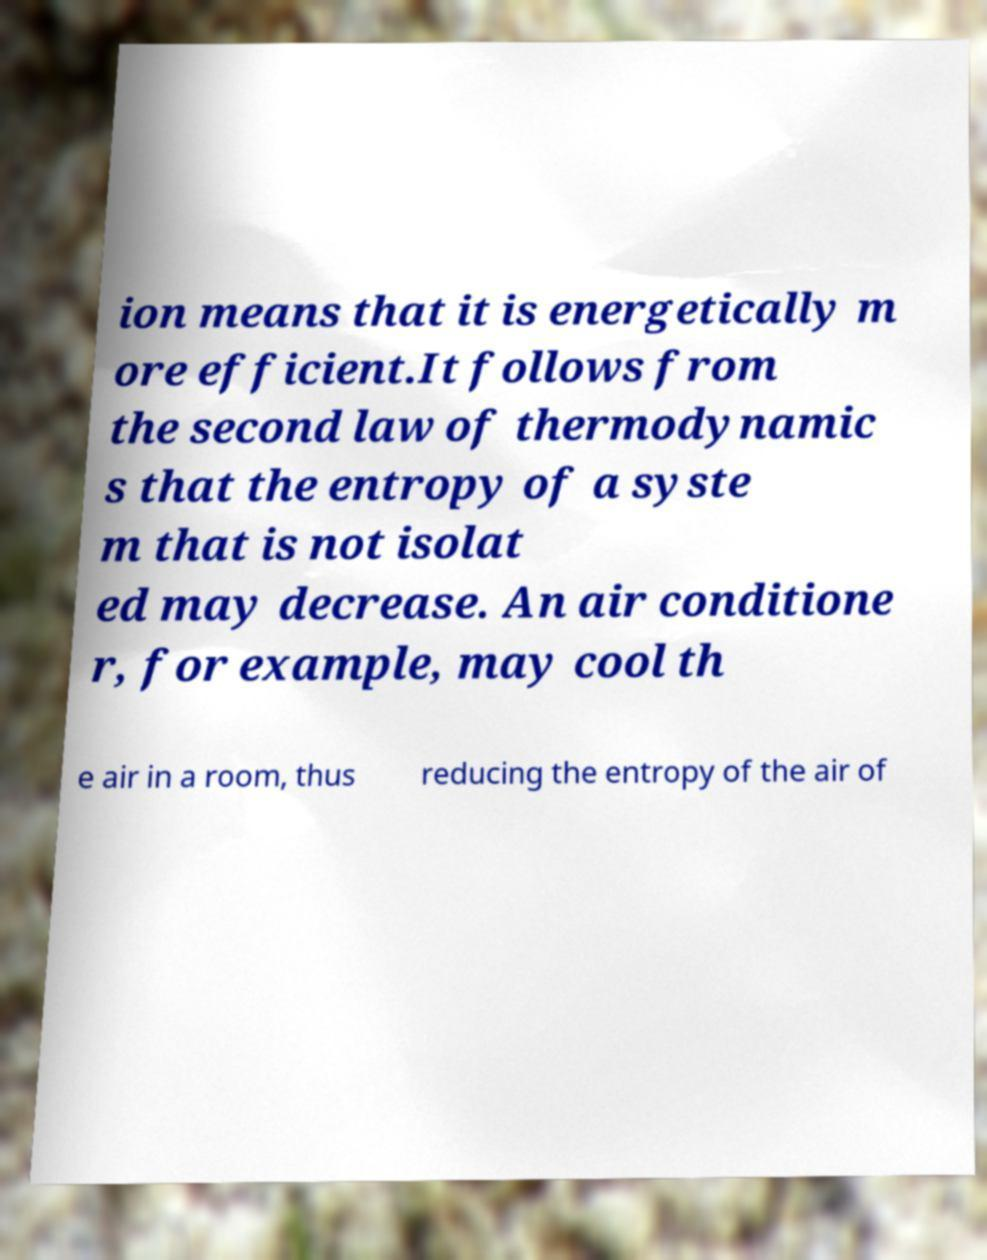Please identify and transcribe the text found in this image. ion means that it is energetically m ore efficient.It follows from the second law of thermodynamic s that the entropy of a syste m that is not isolat ed may decrease. An air conditione r, for example, may cool th e air in a room, thus reducing the entropy of the air of 